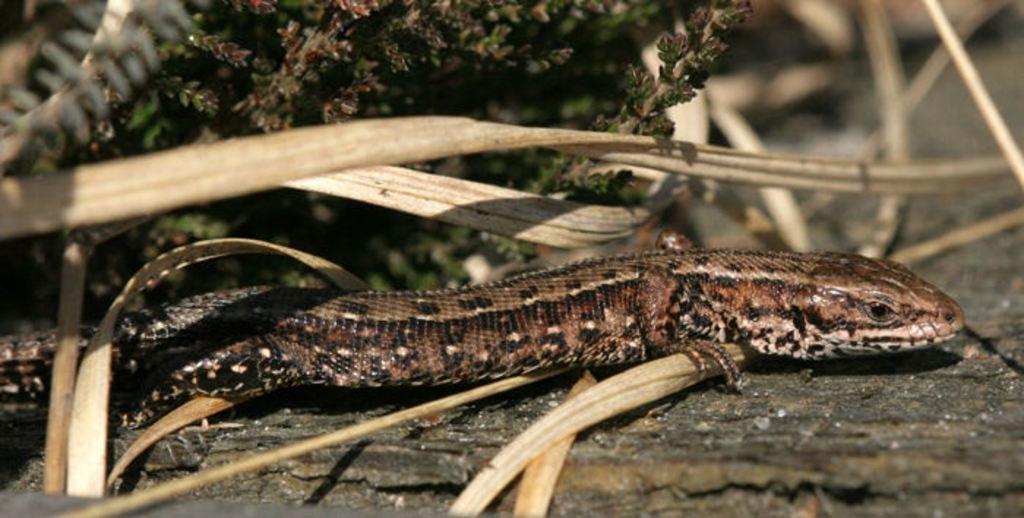Could you give a brief overview of what you see in this image? In this image I can see leaves and in the centre of this image I can see a brown colour lizard. 